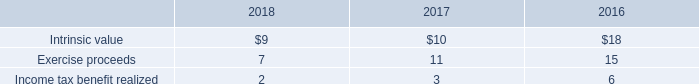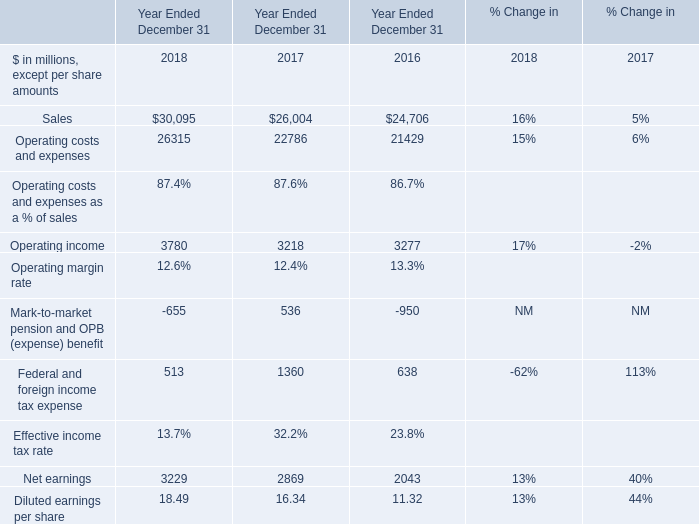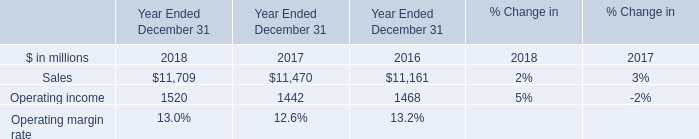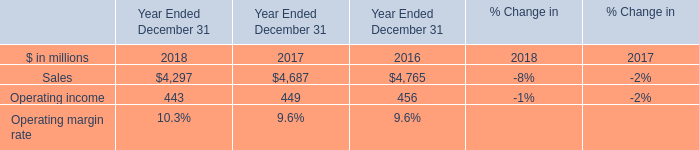What is the average value of Operating income in Table 1 and Sales in Table 3 in 2017? (in million) 
Computations: ((3218 + 4687) / 2)
Answer: 3952.5. 